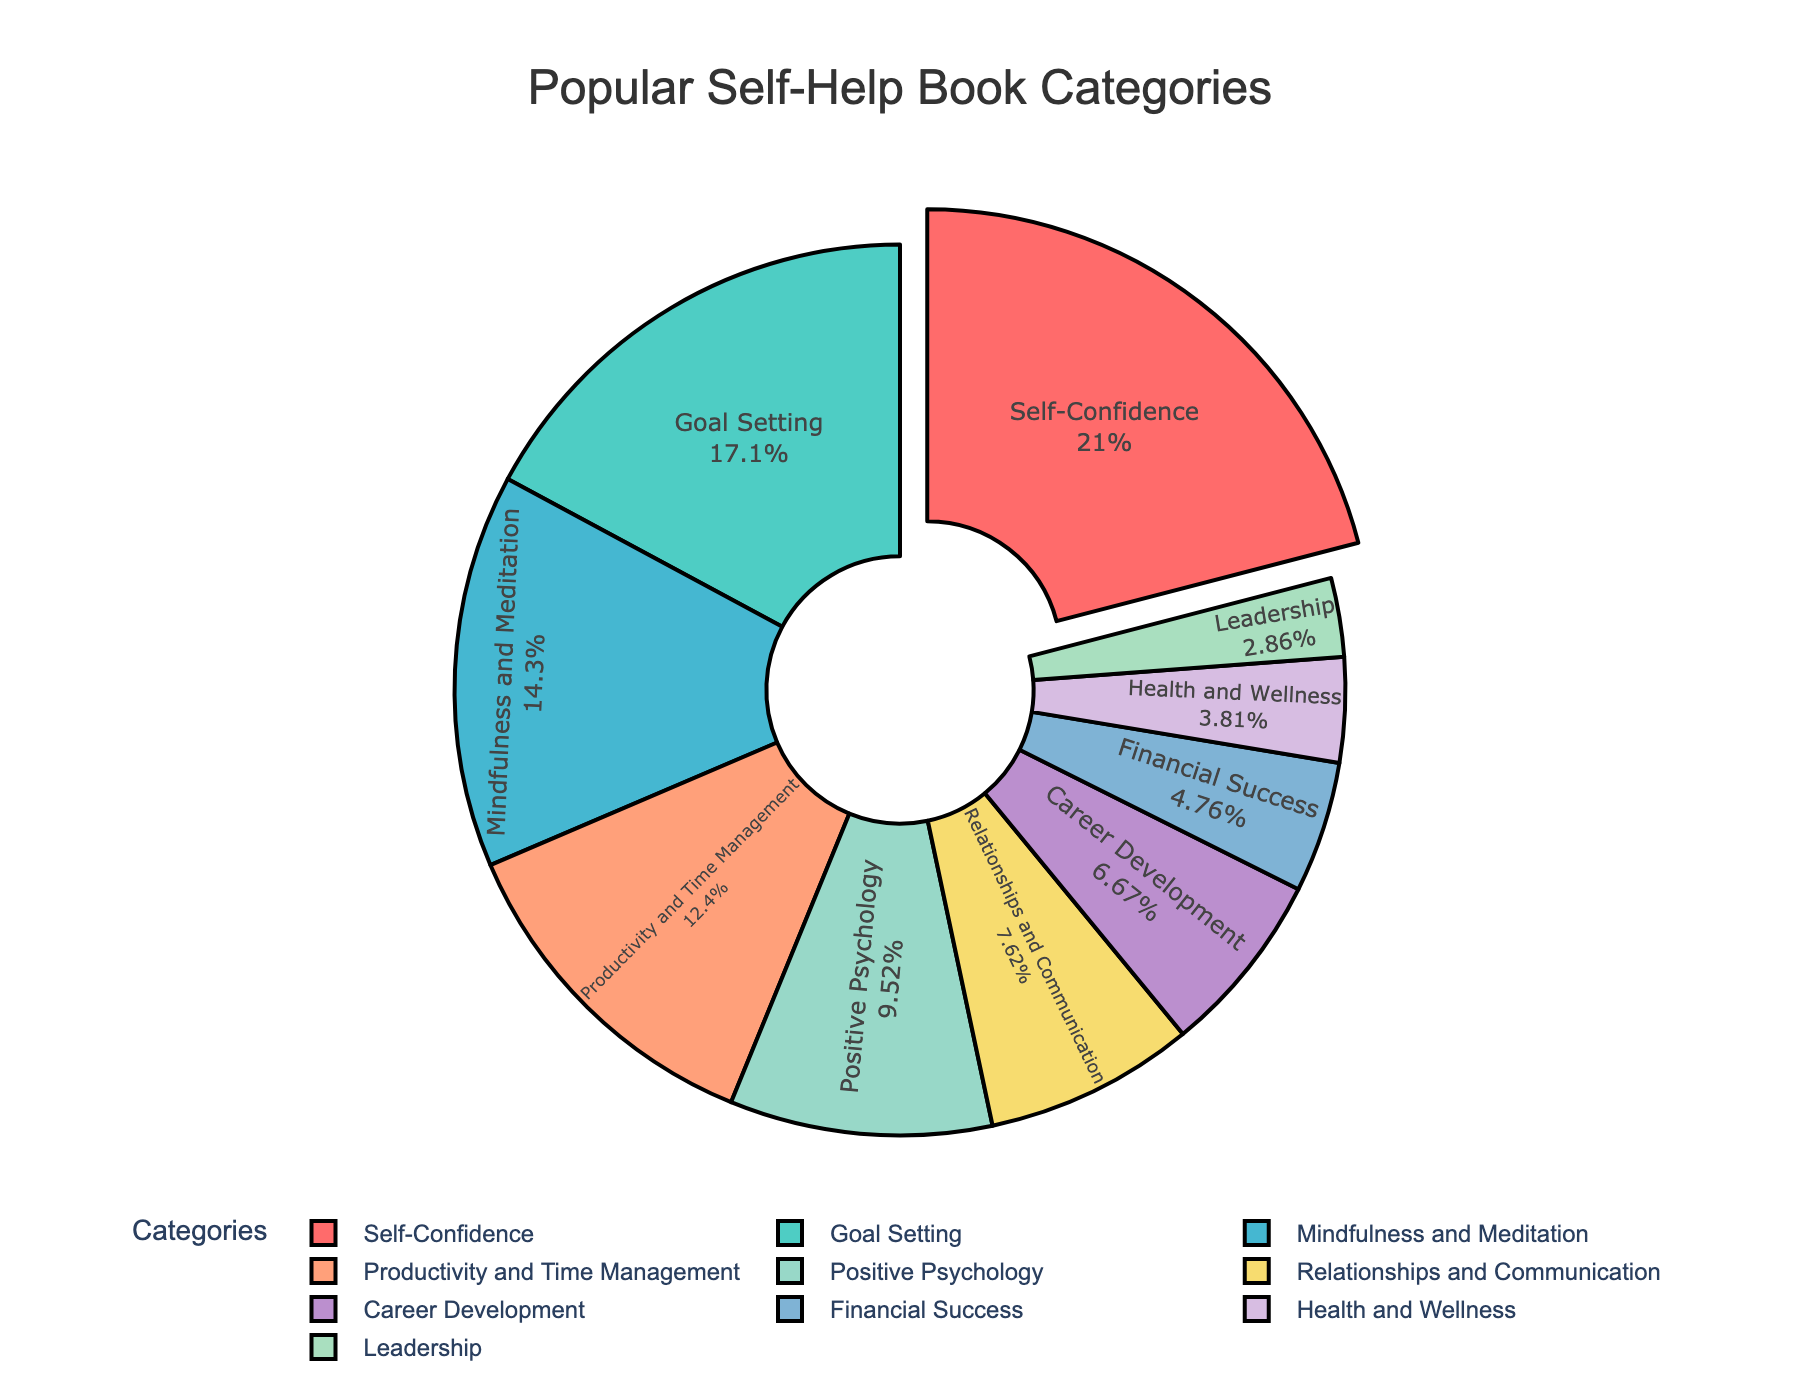What's the most popular self-help book category? The largest section of the pie chart is pulled out and labeled with the highest percentage of 22%. This section is for Self-Confidence.
Answer: Self-Confidence How many categories have a percentage lower than 10%? The pie chart shows the following categories with percentages lower than 10%: Relationships and Communication, Career Development, Financial Success, Health and Wellness, and Leadership. Counting these gives us five categories.
Answer: Five Which category has the smallest percentage? The pie chart has the smallest slice labeled with 3%, which corresponds to the Leadership category.
Answer: Leadership What is the combined percentage of Goal Setting and Productivity and Time Management? From the pie chart, the percentages for Goal Setting and Productivity and Time Management are 18% and 13%, respectively. Adding these gives 18 + 13 = 31%.
Answer: 31% Compare the percentages of Positive Psychology and Career Development. Which one is larger and by how much? The pie chart percentages for Positive Psychology and Career Development are 10% and 7% respectively. The difference is 10% - 7% = 3%. Positive Psychology is larger by 3%.
Answer: Positive Psychology by 3% What percentage of book categories fall under Mindfulness and Meditation? The pie chart shows that Mindfulness and Meditation occupies 15% of the total.
Answer: 15% Sum the percentages of categories related to financial and career improvement. The pie chart lists Financial Success at 5% and Career Development at 7%. Adding these gives 5 + 7 = 12%.
Answer: 12% How many categories are represented by warm colors (red, orange, yellow)? The pie chart uses warm colors for Self-Confidence (red), Goal Setting (light green), and Positive Psychology (yellow). Counting these gives us three categories.
Answer: Three Is the percentage of Relationships and Communication more than half of that of Self-Confidence? The pie chart shows 8% for Relationships and Communication and 22% for Self-Confidence. Half of Self-Confidence is 22% / 2 = 11%. Since 8% is less than 11%, Relationships and Communication is less than half of Self-Confidence.
Answer: No What is the total percentage for categories related to personal well-being (Health and Wellness, Mindfulness and Meditation, Positive Psychology)? From the pie chart, Health and Wellness is 4%, Mindfulness and Meditation is 15%, and Positive Psychology is 10%. Adding these gives 4 + 15 + 10 = 29%.
Answer: 29% 